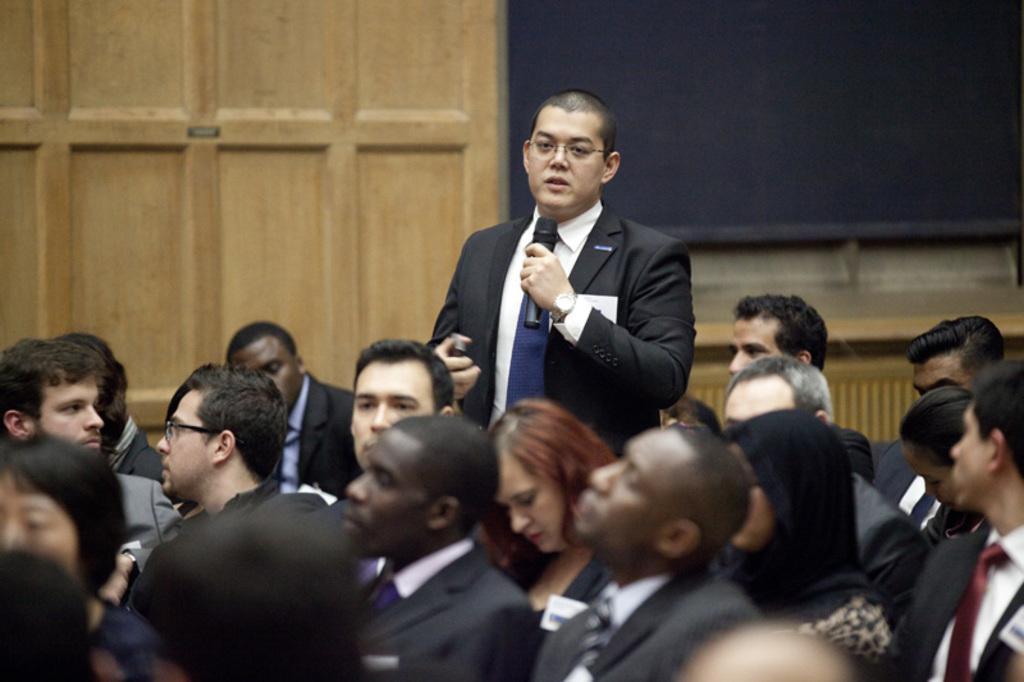Could you give a brief overview of what you see in this image? At the bottom of this image few people are sitting facing towards the left side. In the background there is a person standing, holding a mike in the hand and speaking. In the top right there is a black color board attached to the wall. 